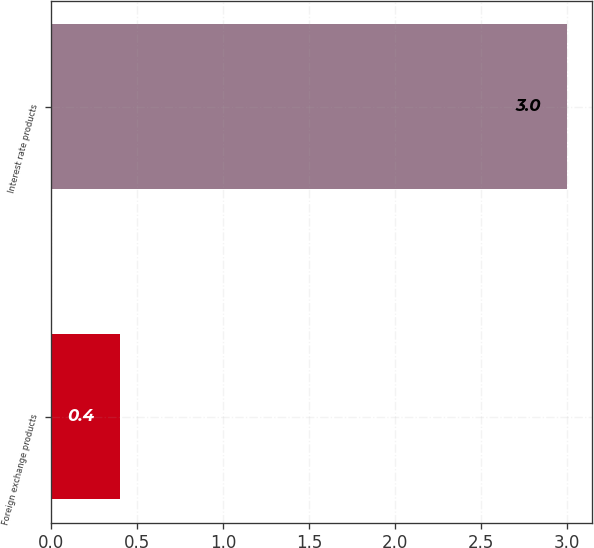<chart> <loc_0><loc_0><loc_500><loc_500><bar_chart><fcel>Foreign exchange products<fcel>Interest rate products<nl><fcel>0.4<fcel>3<nl></chart> 